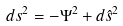<formula> <loc_0><loc_0><loc_500><loc_500>d s ^ { 2 } = - \Psi ^ { 2 } + d \hat { s } ^ { 2 }</formula> 